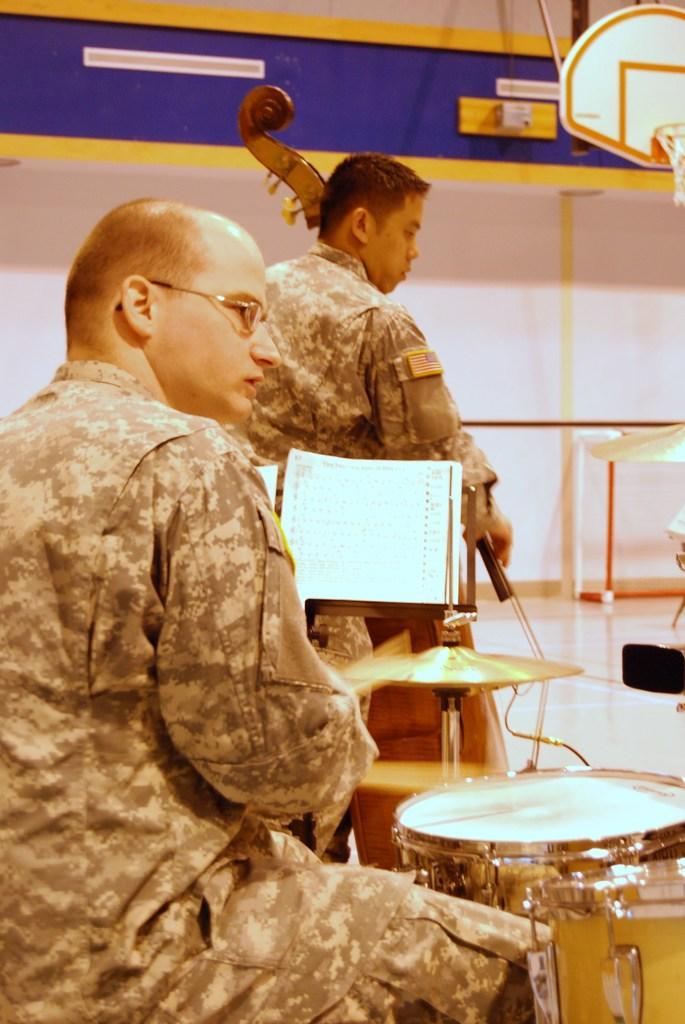How would you summarize this image in a sentence or two? A picture with two people the one among them is having the spectacles and bald head. They are wearing same color dress and also the one with spectacles is sitting in front of a band and the other guy who is standing is holding an instrument. 